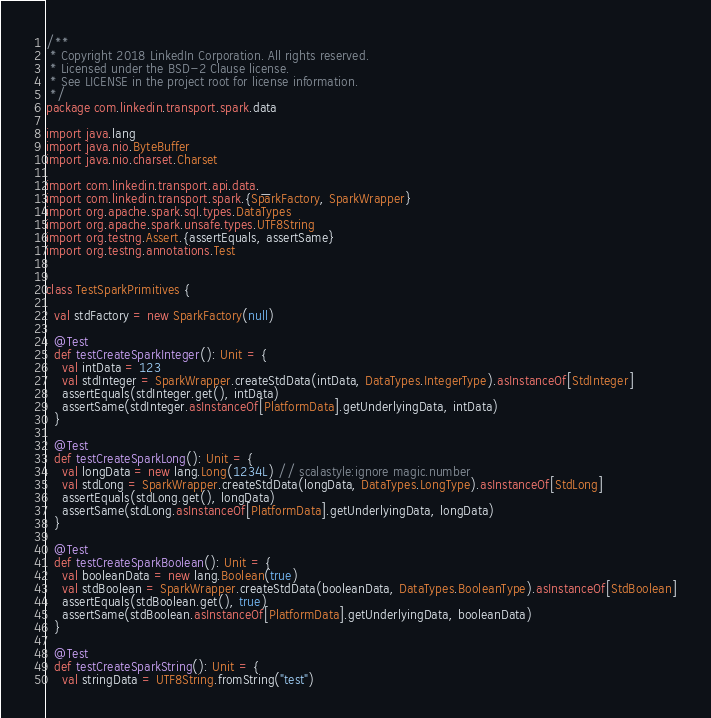<code> <loc_0><loc_0><loc_500><loc_500><_Scala_>/**
 * Copyright 2018 LinkedIn Corporation. All rights reserved.
 * Licensed under the BSD-2 Clause license.
 * See LICENSE in the project root for license information.
 */
package com.linkedin.transport.spark.data

import java.lang
import java.nio.ByteBuffer
import java.nio.charset.Charset

import com.linkedin.transport.api.data._
import com.linkedin.transport.spark.{SparkFactory, SparkWrapper}
import org.apache.spark.sql.types.DataTypes
import org.apache.spark.unsafe.types.UTF8String
import org.testng.Assert.{assertEquals, assertSame}
import org.testng.annotations.Test


class TestSparkPrimitives {

  val stdFactory = new SparkFactory(null)

  @Test
  def testCreateSparkInteger(): Unit = {
    val intData = 123
    val stdInteger = SparkWrapper.createStdData(intData, DataTypes.IntegerType).asInstanceOf[StdInteger]
    assertEquals(stdInteger.get(), intData)
    assertSame(stdInteger.asInstanceOf[PlatformData].getUnderlyingData, intData)
  }

  @Test
  def testCreateSparkLong(): Unit = {
    val longData = new lang.Long(1234L) // scalastyle:ignore magic.number
    val stdLong = SparkWrapper.createStdData(longData, DataTypes.LongType).asInstanceOf[StdLong]
    assertEquals(stdLong.get(), longData)
    assertSame(stdLong.asInstanceOf[PlatformData].getUnderlyingData, longData)
  }

  @Test
  def testCreateSparkBoolean(): Unit = {
    val booleanData = new lang.Boolean(true)
    val stdBoolean = SparkWrapper.createStdData(booleanData, DataTypes.BooleanType).asInstanceOf[StdBoolean]
    assertEquals(stdBoolean.get(), true)
    assertSame(stdBoolean.asInstanceOf[PlatformData].getUnderlyingData, booleanData)
  }

  @Test
  def testCreateSparkString(): Unit = {
    val stringData = UTF8String.fromString("test")</code> 